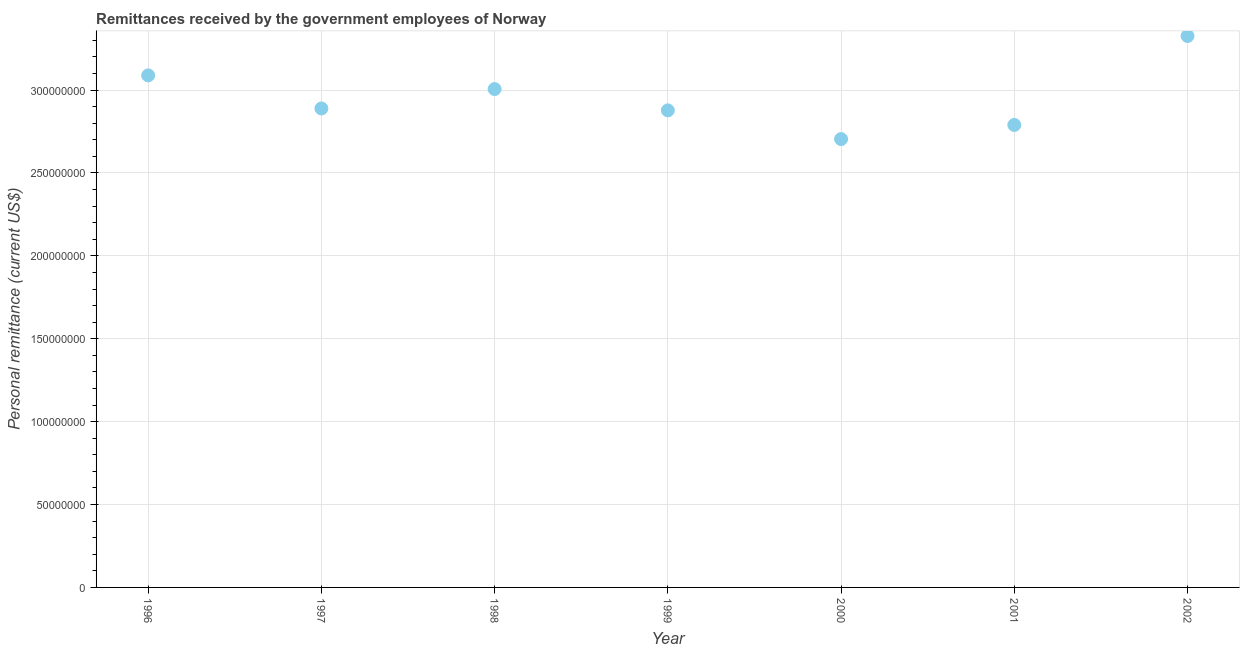What is the personal remittances in 1997?
Offer a very short reply. 2.89e+08. Across all years, what is the maximum personal remittances?
Your answer should be very brief. 3.33e+08. Across all years, what is the minimum personal remittances?
Make the answer very short. 2.70e+08. In which year was the personal remittances minimum?
Offer a terse response. 2000. What is the sum of the personal remittances?
Offer a terse response. 2.07e+09. What is the difference between the personal remittances in 1996 and 2000?
Your answer should be compact. 3.84e+07. What is the average personal remittances per year?
Your response must be concise. 2.95e+08. What is the median personal remittances?
Ensure brevity in your answer.  2.89e+08. In how many years, is the personal remittances greater than 170000000 US$?
Keep it short and to the point. 7. What is the ratio of the personal remittances in 1996 to that in 2002?
Your answer should be very brief. 0.93. Is the personal remittances in 1999 less than that in 2002?
Give a very brief answer. Yes. What is the difference between the highest and the second highest personal remittances?
Keep it short and to the point. 2.38e+07. What is the difference between the highest and the lowest personal remittances?
Give a very brief answer. 6.22e+07. Does the graph contain any zero values?
Give a very brief answer. No. What is the title of the graph?
Give a very brief answer. Remittances received by the government employees of Norway. What is the label or title of the Y-axis?
Your answer should be compact. Personal remittance (current US$). What is the Personal remittance (current US$) in 1996?
Your answer should be compact. 3.09e+08. What is the Personal remittance (current US$) in 1997?
Ensure brevity in your answer.  2.89e+08. What is the Personal remittance (current US$) in 1998?
Your answer should be very brief. 3.01e+08. What is the Personal remittance (current US$) in 1999?
Make the answer very short. 2.88e+08. What is the Personal remittance (current US$) in 2000?
Offer a terse response. 2.70e+08. What is the Personal remittance (current US$) in 2001?
Keep it short and to the point. 2.79e+08. What is the Personal remittance (current US$) in 2002?
Ensure brevity in your answer.  3.33e+08. What is the difference between the Personal remittance (current US$) in 1996 and 1997?
Keep it short and to the point. 1.99e+07. What is the difference between the Personal remittance (current US$) in 1996 and 1998?
Offer a terse response. 8.26e+06. What is the difference between the Personal remittance (current US$) in 1996 and 1999?
Provide a short and direct response. 2.11e+07. What is the difference between the Personal remittance (current US$) in 1996 and 2000?
Your answer should be compact. 3.84e+07. What is the difference between the Personal remittance (current US$) in 1996 and 2001?
Your response must be concise. 2.99e+07. What is the difference between the Personal remittance (current US$) in 1996 and 2002?
Make the answer very short. -2.38e+07. What is the difference between the Personal remittance (current US$) in 1997 and 1998?
Your answer should be very brief. -1.17e+07. What is the difference between the Personal remittance (current US$) in 1997 and 1999?
Your response must be concise. 1.16e+06. What is the difference between the Personal remittance (current US$) in 1997 and 2000?
Make the answer very short. 1.85e+07. What is the difference between the Personal remittance (current US$) in 1997 and 2001?
Ensure brevity in your answer.  9.94e+06. What is the difference between the Personal remittance (current US$) in 1997 and 2002?
Give a very brief answer. -4.37e+07. What is the difference between the Personal remittance (current US$) in 1998 and 1999?
Make the answer very short. 1.29e+07. What is the difference between the Personal remittance (current US$) in 1998 and 2000?
Give a very brief answer. 3.02e+07. What is the difference between the Personal remittance (current US$) in 1998 and 2001?
Provide a succinct answer. 2.16e+07. What is the difference between the Personal remittance (current US$) in 1998 and 2002?
Your answer should be compact. -3.20e+07. What is the difference between the Personal remittance (current US$) in 1999 and 2000?
Provide a succinct answer. 1.73e+07. What is the difference between the Personal remittance (current US$) in 1999 and 2001?
Your answer should be very brief. 8.79e+06. What is the difference between the Personal remittance (current US$) in 1999 and 2002?
Give a very brief answer. -4.49e+07. What is the difference between the Personal remittance (current US$) in 2000 and 2001?
Make the answer very short. -8.52e+06. What is the difference between the Personal remittance (current US$) in 2000 and 2002?
Your answer should be very brief. -6.22e+07. What is the difference between the Personal remittance (current US$) in 2001 and 2002?
Your response must be concise. -5.37e+07. What is the ratio of the Personal remittance (current US$) in 1996 to that in 1997?
Your response must be concise. 1.07. What is the ratio of the Personal remittance (current US$) in 1996 to that in 1998?
Keep it short and to the point. 1.03. What is the ratio of the Personal remittance (current US$) in 1996 to that in 1999?
Your response must be concise. 1.07. What is the ratio of the Personal remittance (current US$) in 1996 to that in 2000?
Give a very brief answer. 1.14. What is the ratio of the Personal remittance (current US$) in 1996 to that in 2001?
Ensure brevity in your answer.  1.11. What is the ratio of the Personal remittance (current US$) in 1996 to that in 2002?
Your answer should be compact. 0.93. What is the ratio of the Personal remittance (current US$) in 1997 to that in 2000?
Offer a very short reply. 1.07. What is the ratio of the Personal remittance (current US$) in 1997 to that in 2001?
Your answer should be compact. 1.04. What is the ratio of the Personal remittance (current US$) in 1997 to that in 2002?
Your response must be concise. 0.87. What is the ratio of the Personal remittance (current US$) in 1998 to that in 1999?
Give a very brief answer. 1.04. What is the ratio of the Personal remittance (current US$) in 1998 to that in 2000?
Provide a succinct answer. 1.11. What is the ratio of the Personal remittance (current US$) in 1998 to that in 2001?
Your response must be concise. 1.08. What is the ratio of the Personal remittance (current US$) in 1998 to that in 2002?
Make the answer very short. 0.9. What is the ratio of the Personal remittance (current US$) in 1999 to that in 2000?
Your answer should be compact. 1.06. What is the ratio of the Personal remittance (current US$) in 1999 to that in 2001?
Provide a short and direct response. 1.03. What is the ratio of the Personal remittance (current US$) in 1999 to that in 2002?
Offer a very short reply. 0.86. What is the ratio of the Personal remittance (current US$) in 2000 to that in 2001?
Provide a succinct answer. 0.97. What is the ratio of the Personal remittance (current US$) in 2000 to that in 2002?
Ensure brevity in your answer.  0.81. What is the ratio of the Personal remittance (current US$) in 2001 to that in 2002?
Provide a short and direct response. 0.84. 